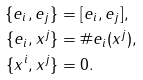Convert formula to latex. <formula><loc_0><loc_0><loc_500><loc_500>\{ e _ { i } , e _ { j } \} & = [ e _ { i } , e _ { j } ] , \\ \{ e _ { i } , x ^ { j } \} & = \# e _ { i } ( x ^ { j } ) , \\ \{ x ^ { i } , x ^ { j } \} & = 0 .</formula> 